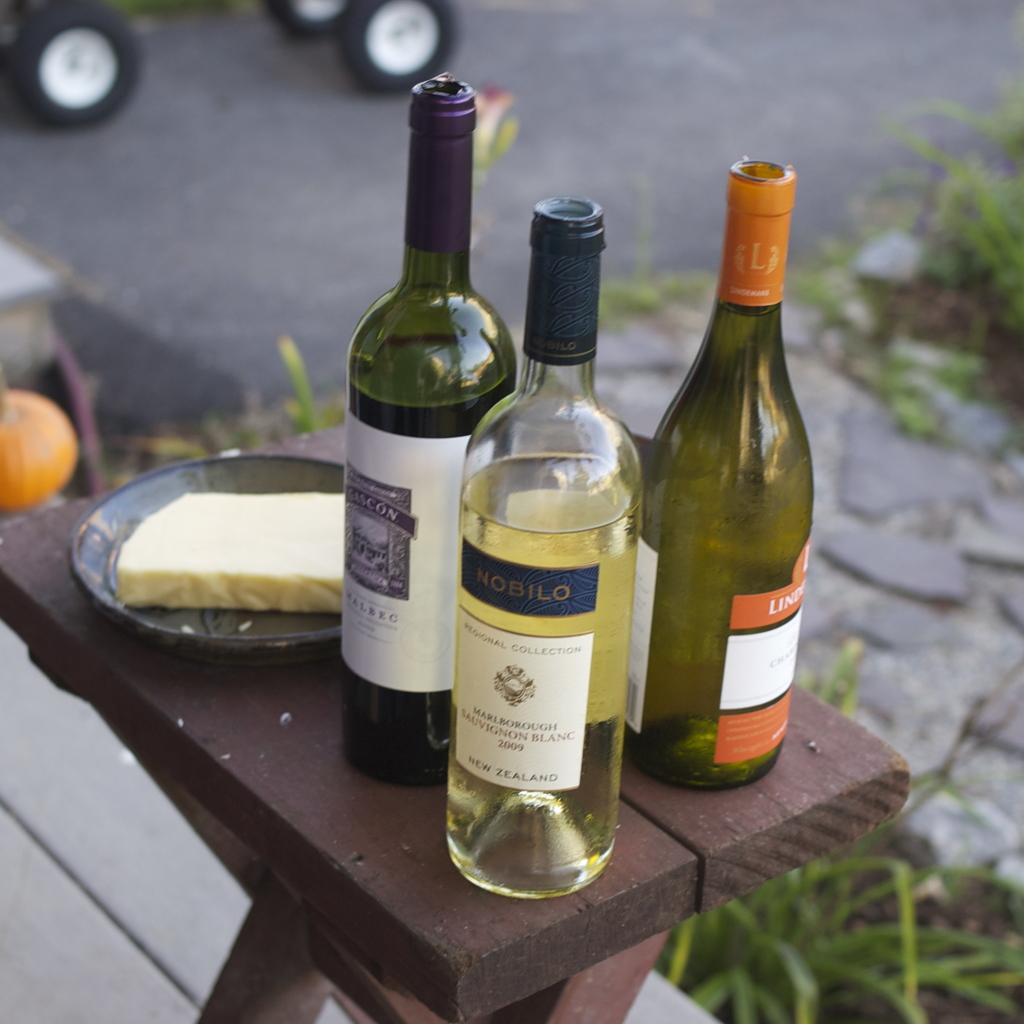How many bottles are visible in the image? There are three bottles in the image. What colors are the bottles? Two of the bottles are green, and one is golden. What is located on the stool in the image? There is a bowl on a stool in the image. What type of vegetation can be seen on the floor in the image? There are plants on the floor in the image. What type of jelly can be seen hanging from the golden bottle in the image? There is no jelly present in the image, and the golden bottle is not depicted as having anything hanging from it. 